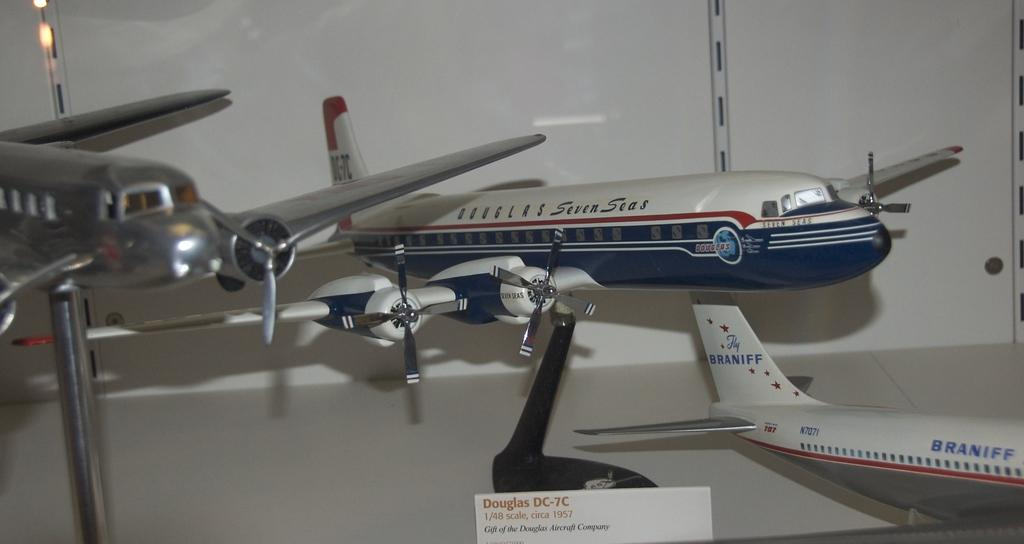What type of toys are present in the image? There are toy planes in the image. What can be seen in the background of the image? There is a wall in the background of the image. What is written on the card at the bottom of the image? Text is written on a is written on the card at the bottom of the image. What type of blood is visible on the toy planes in the image? There is no blood visible on the toy planes in the image. How many feet are present on the toy planes in the image? Toy planes do not have feet, so this question cannot be answered. 